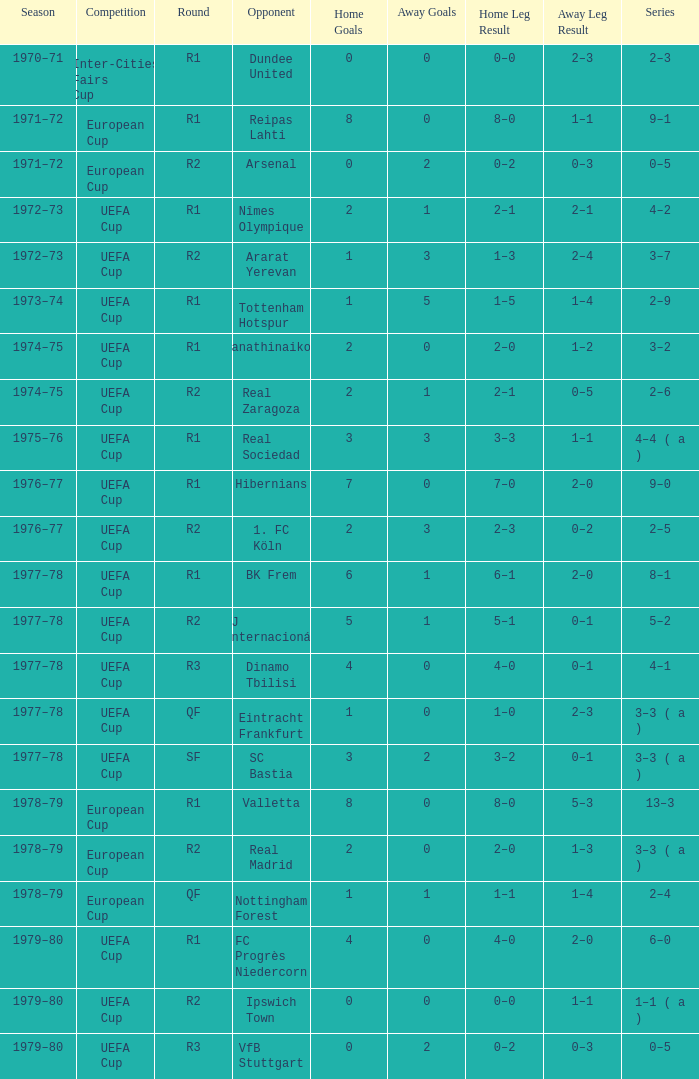Which Season has an Opponent of hibernians? 1976–77. 